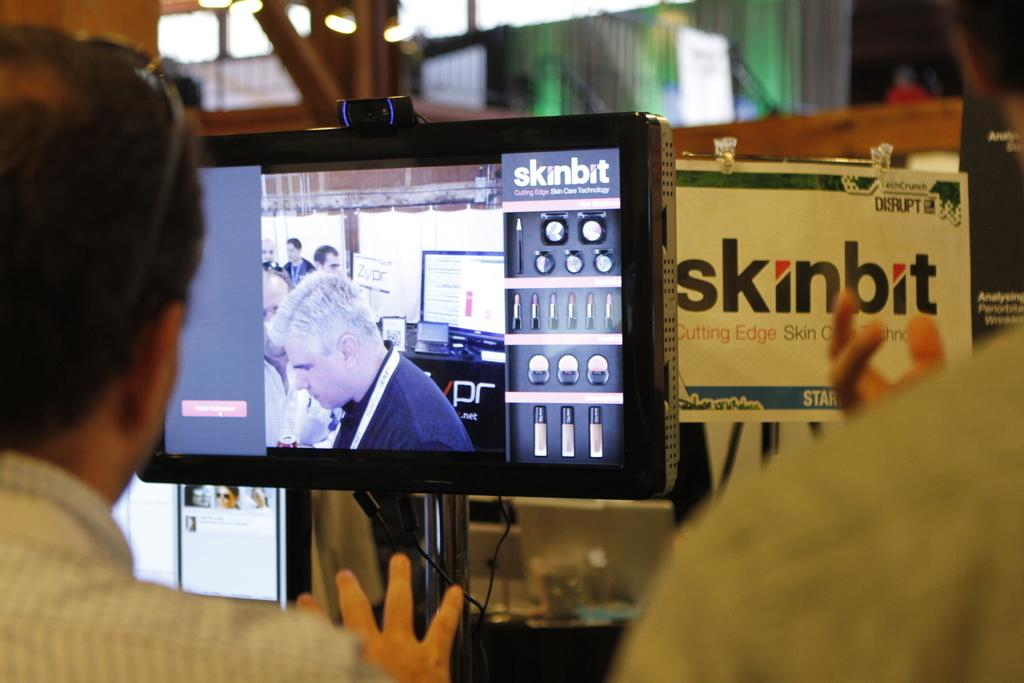<image>
Present a compact description of the photo's key features. A man is shown on a monitor about Skinbit. 